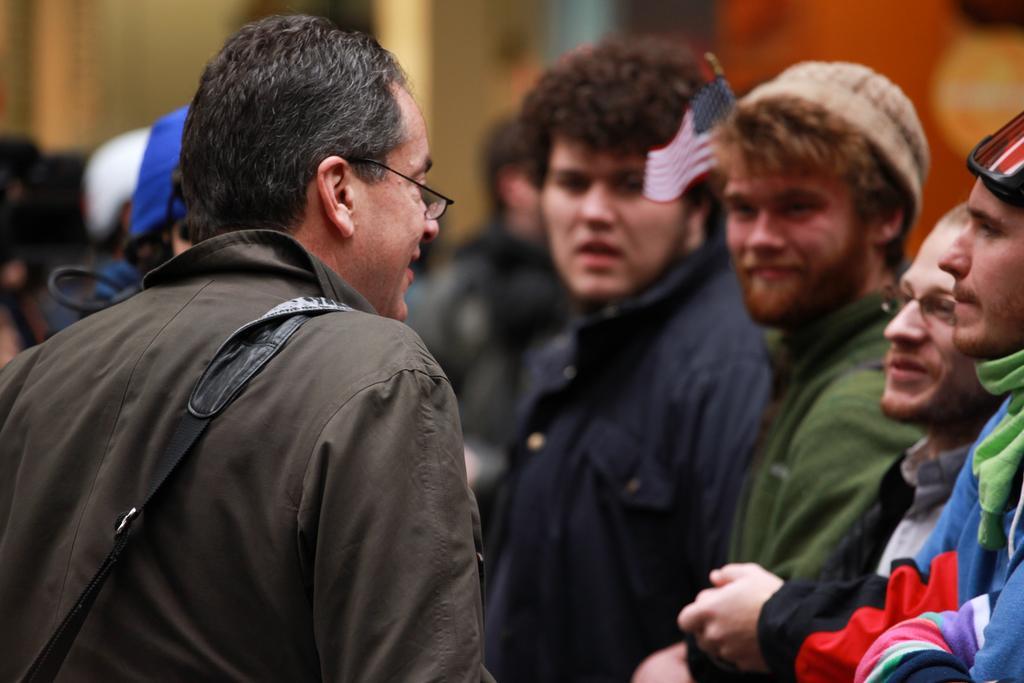Could you give a brief overview of what you see in this image? In this image we can see a man wearing the glasses and also a bag on the left. On the right we can see the people and the background is not clear. 